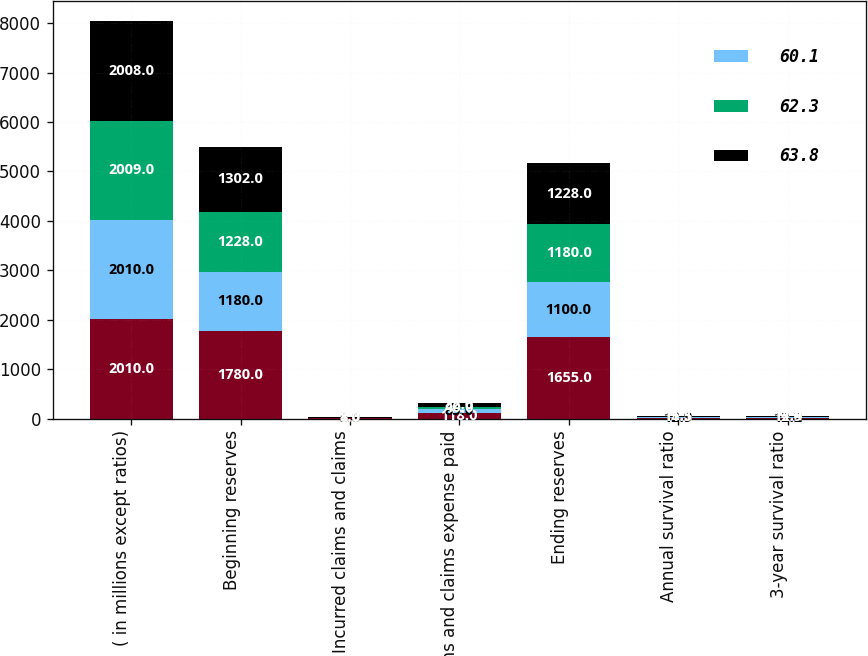Convert chart to OTSL. <chart><loc_0><loc_0><loc_500><loc_500><stacked_bar_chart><ecel><fcel>( in millions except ratios)<fcel>Beginning reserves<fcel>Incurred claims and claims<fcel>Claims and claims expense paid<fcel>Ending reserves<fcel>Annual survival ratio<fcel>3-year survival ratio<nl><fcel>nan<fcel>2010<fcel>1780<fcel>7<fcel>118<fcel>1655<fcel>14<fcel>12.6<nl><fcel>60.1<fcel>2010<fcel>1180<fcel>5<fcel>85<fcel>1100<fcel>12.9<fcel>12.2<nl><fcel>62.3<fcel>2009<fcel>1228<fcel>8<fcel>40<fcel>1180<fcel>11.5<fcel>12.9<nl><fcel>63.8<fcel>2008<fcel>1302<fcel>8<fcel>82<fcel>1228<fcel>15.1<fcel>14.4<nl></chart> 